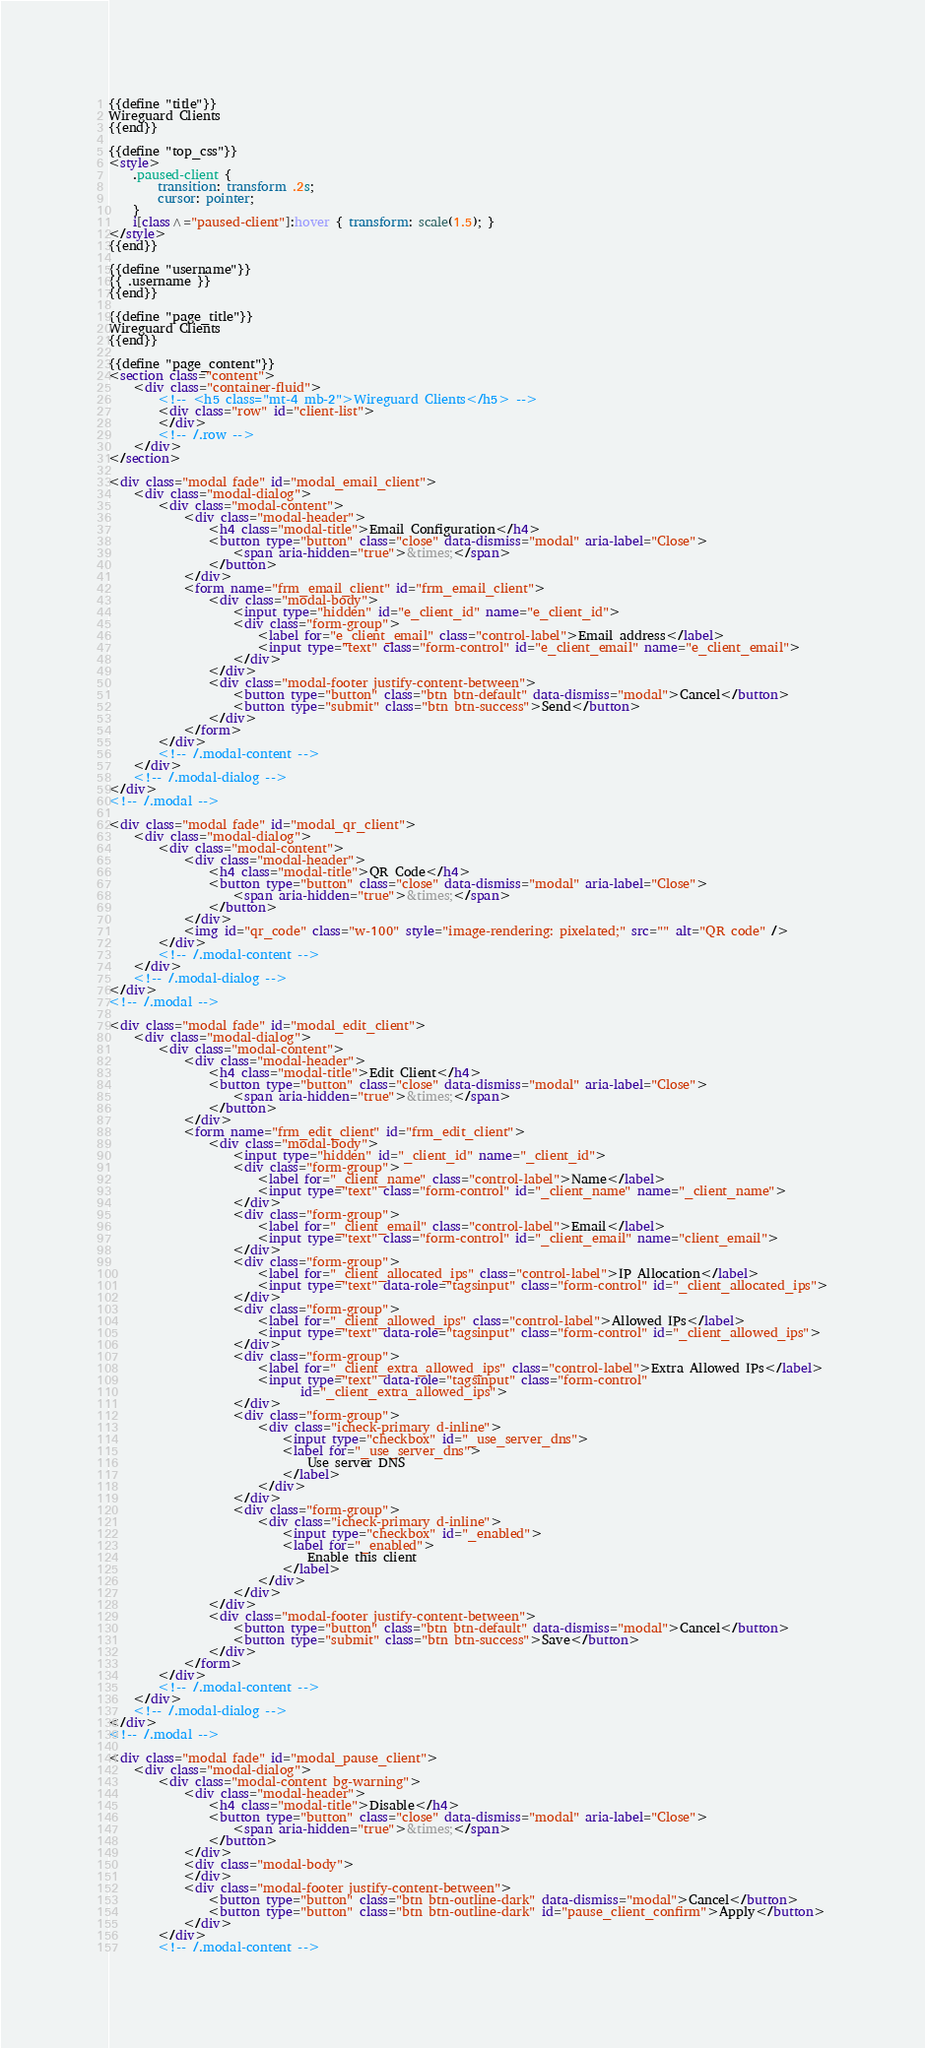Convert code to text. <code><loc_0><loc_0><loc_500><loc_500><_HTML_>{{define "title"}}
Wireguard Clients
{{end}}

{{define "top_css"}}
<style>
    .paused-client {
        transition: transform .2s;
        cursor: pointer;
    }
    i[class^="paused-client"]:hover { transform: scale(1.5); }
</style>
{{end}}

{{define "username"}}
{{ .username }}
{{end}}

{{define "page_title"}}
Wireguard Clients
{{end}}

{{define "page_content"}}
<section class="content">
    <div class="container-fluid">
        <!-- <h5 class="mt-4 mb-2">Wireguard Clients</h5> -->
        <div class="row" id="client-list">
        </div>
        <!-- /.row -->
    </div>
</section>

<div class="modal fade" id="modal_email_client">
    <div class="modal-dialog">
        <div class="modal-content">
            <div class="modal-header">
                <h4 class="modal-title">Email Configuration</h4>
                <button type="button" class="close" data-dismiss="modal" aria-label="Close">
                    <span aria-hidden="true">&times;</span>
                </button>
            </div>
            <form name="frm_email_client" id="frm_email_client">
                <div class="modal-body">
                    <input type="hidden" id="e_client_id" name="e_client_id">
                    <div class="form-group">
                        <label for="e_client_email" class="control-label">Email address</label>
                        <input type="text" class="form-control" id="e_client_email" name="e_client_email">
                    </div>
                </div>
                <div class="modal-footer justify-content-between">
                    <button type="button" class="btn btn-default" data-dismiss="modal">Cancel</button>
                    <button type="submit" class="btn btn-success">Send</button>
                </div>
            </form>
        </div>
        <!-- /.modal-content -->
    </div>
    <!-- /.modal-dialog -->
</div>
<!-- /.modal -->

<div class="modal fade" id="modal_qr_client">
    <div class="modal-dialog">
        <div class="modal-content">
            <div class="modal-header">
                <h4 class="modal-title">QR Code</h4>
                <button type="button" class="close" data-dismiss="modal" aria-label="Close">
                    <span aria-hidden="true">&times;</span>
                </button>
            </div>
            <img id="qr_code" class="w-100" style="image-rendering: pixelated;" src="" alt="QR code" />
        </div>
        <!-- /.modal-content -->
    </div>
    <!-- /.modal-dialog -->
</div>
<!-- /.modal -->

<div class="modal fade" id="modal_edit_client">
    <div class="modal-dialog">
        <div class="modal-content">
            <div class="modal-header">
                <h4 class="modal-title">Edit Client</h4>
                <button type="button" class="close" data-dismiss="modal" aria-label="Close">
                    <span aria-hidden="true">&times;</span>
                </button>
            </div>
            <form name="frm_edit_client" id="frm_edit_client">
                <div class="modal-body">
                    <input type="hidden" id="_client_id" name="_client_id">
                    <div class="form-group">
                        <label for="_client_name" class="control-label">Name</label>
                        <input type="text" class="form-control" id="_client_name" name="_client_name">
                    </div>
                    <div class="form-group">
                        <label for="_client_email" class="control-label">Email</label>
                        <input type="text" class="form-control" id="_client_email" name="client_email">
                    </div>
                    <div class="form-group">
                        <label for="_client_allocated_ips" class="control-label">IP Allocation</label>
                        <input type="text" data-role="tagsinput" class="form-control" id="_client_allocated_ips">
                    </div>
                    <div class="form-group">
                        <label for="_client_allowed_ips" class="control-label">Allowed IPs</label>
                        <input type="text" data-role="tagsinput" class="form-control" id="_client_allowed_ips">
                    </div>
                    <div class="form-group">
                        <label for="_client_extra_allowed_ips" class="control-label">Extra Allowed IPs</label>
                        <input type="text" data-role="tagsinput" class="form-control"
                               id="_client_extra_allowed_ips">
                    </div>
                    <div class="form-group">
                        <div class="icheck-primary d-inline">
                            <input type="checkbox" id="_use_server_dns">
                            <label for="_use_server_dns">
                                Use server DNS
                            </label>
                        </div>
                    </div>
                    <div class="form-group">
                        <div class="icheck-primary d-inline">
                            <input type="checkbox" id="_enabled">
                            <label for="_enabled">
                                Enable this client
                            </label>
                        </div>
                    </div>
                </div>
                <div class="modal-footer justify-content-between">
                    <button type="button" class="btn btn-default" data-dismiss="modal">Cancel</button>
                    <button type="submit" class="btn btn-success">Save</button>
                </div>
            </form>
        </div>
        <!-- /.modal-content -->
    </div>
    <!-- /.modal-dialog -->
</div>
<!-- /.modal -->

<div class="modal fade" id="modal_pause_client">
    <div class="modal-dialog">
        <div class="modal-content bg-warning">
            <div class="modal-header">
                <h4 class="modal-title">Disable</h4>
                <button type="button" class="close" data-dismiss="modal" aria-label="Close">
                    <span aria-hidden="true">&times;</span>
                </button>
            </div>
            <div class="modal-body">
            </div>
            <div class="modal-footer justify-content-between">
                <button type="button" class="btn btn-outline-dark" data-dismiss="modal">Cancel</button>
                <button type="button" class="btn btn-outline-dark" id="pause_client_confirm">Apply</button>
            </div>
        </div>
        <!-- /.modal-content --></code> 